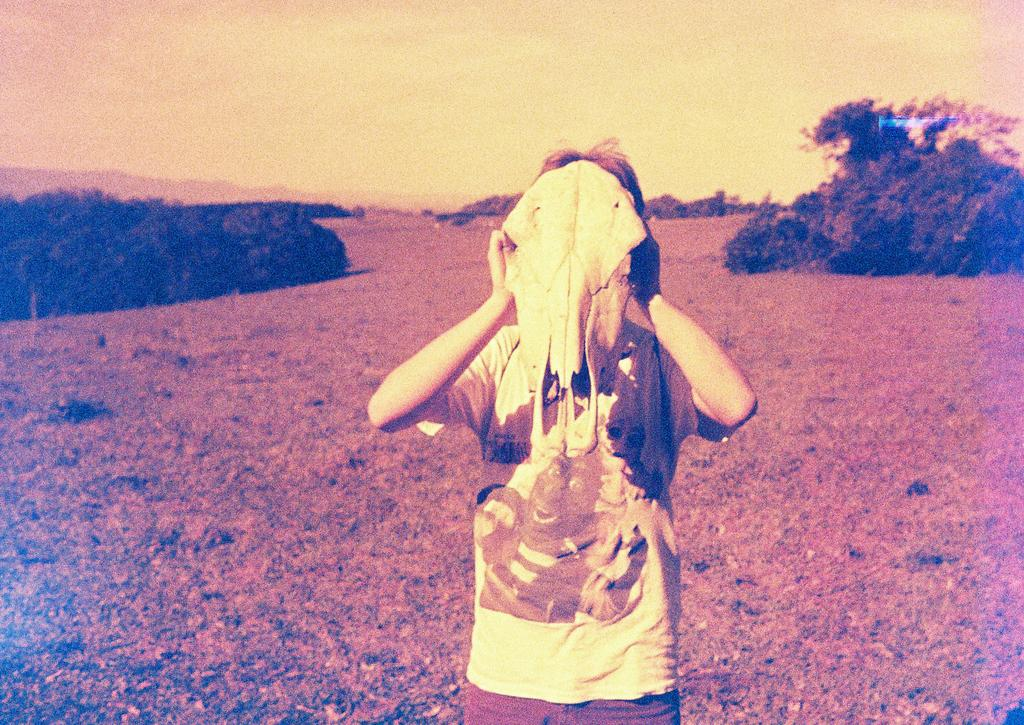Who or what is the main subject in the middle of the image? There is a person in the middle of the image. What is the person wearing? The person is wearing a t-shirt. What type of vegetation can be seen on the left side of the image? There are trees on the left side of the image. What is visible at the top of the image? The sky is visible at the top of the image. How many boxes can be seen stacked on top of each other in the image? There are no boxes present in the image. What type of bucket is being used by the person in the image? There is no bucket visible in the image. 